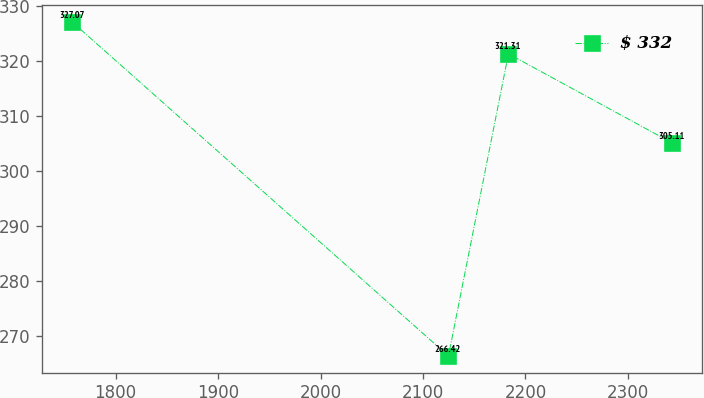Convert chart to OTSL. <chart><loc_0><loc_0><loc_500><loc_500><line_chart><ecel><fcel>$ 332<nl><fcel>1757.71<fcel>327.07<nl><fcel>2124.8<fcel>266.42<nl><fcel>2183.36<fcel>321.31<nl><fcel>2343.32<fcel>305.11<nl></chart> 